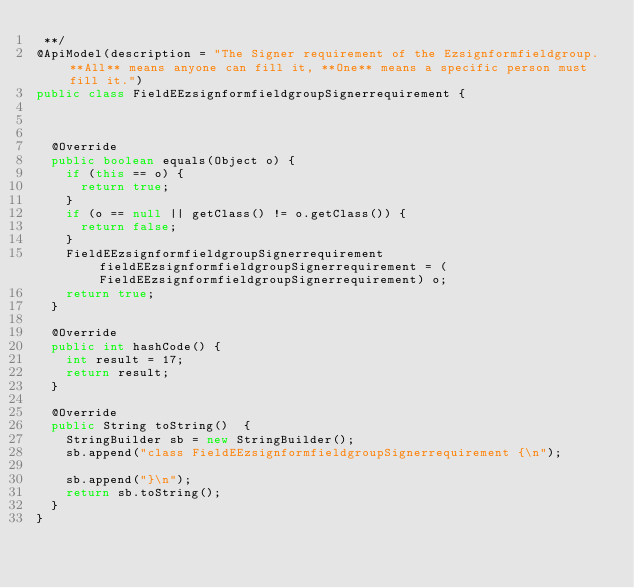<code> <loc_0><loc_0><loc_500><loc_500><_Java_> **/
@ApiModel(description = "The Signer requirement of the Ezsignformfieldgroup. **All** means anyone can fill it, **One** means a specific person must fill it.")
public class FieldEEzsignformfieldgroupSignerrequirement {
  


  @Override
  public boolean equals(Object o) {
    if (this == o) {
      return true;
    }
    if (o == null || getClass() != o.getClass()) {
      return false;
    }
    FieldEEzsignformfieldgroupSignerrequirement fieldEEzsignformfieldgroupSignerrequirement = (FieldEEzsignformfieldgroupSignerrequirement) o;
    return true;
  }

  @Override
  public int hashCode() {
    int result = 17;
    return result;
  }

  @Override
  public String toString()  {
    StringBuilder sb = new StringBuilder();
    sb.append("class FieldEEzsignformfieldgroupSignerrequirement {\n");
    
    sb.append("}\n");
    return sb.toString();
  }
}
</code> 